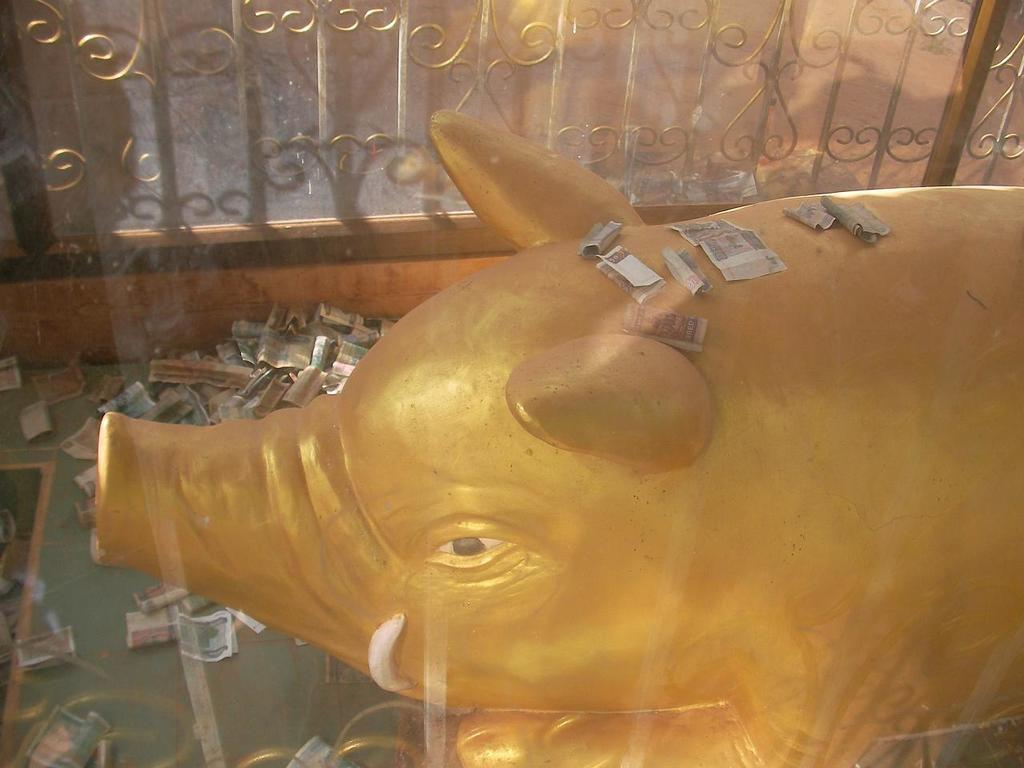What type of object is depicted in the image? There is an animal sculpture in the image. What else can be seen in the image besides the sculpture? There are currency notes in the image. What is the background or surrounding of the sculpture? There is a fence in the image. What type of blood is visible on the animal sculpture in the image? There is no blood visible on the animal sculpture in the image. Can you provide an example of a similar sculpture in another image? The provided facts do not give any information about other images or sculptures, so it is not possible to provide an example. 